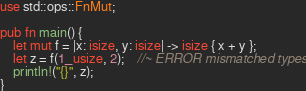Convert code to text. <code><loc_0><loc_0><loc_500><loc_500><_Rust_>use std::ops::FnMut;

pub fn main() {
    let mut f = |x: isize, y: isize| -> isize { x + y };
    let z = f(1_usize, 2);    //~ ERROR mismatched types
    println!("{}", z);
}
</code> 